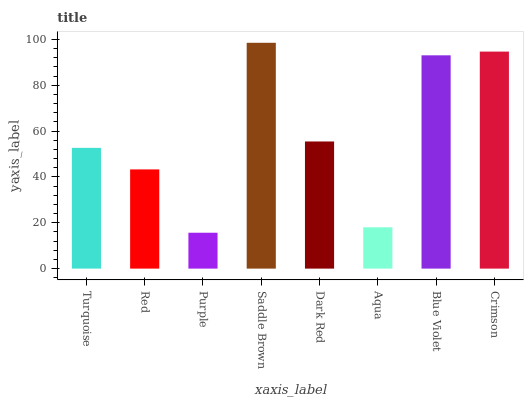Is Purple the minimum?
Answer yes or no. Yes. Is Saddle Brown the maximum?
Answer yes or no. Yes. Is Red the minimum?
Answer yes or no. No. Is Red the maximum?
Answer yes or no. No. Is Turquoise greater than Red?
Answer yes or no. Yes. Is Red less than Turquoise?
Answer yes or no. Yes. Is Red greater than Turquoise?
Answer yes or no. No. Is Turquoise less than Red?
Answer yes or no. No. Is Dark Red the high median?
Answer yes or no. Yes. Is Turquoise the low median?
Answer yes or no. Yes. Is Blue Violet the high median?
Answer yes or no. No. Is Blue Violet the low median?
Answer yes or no. No. 